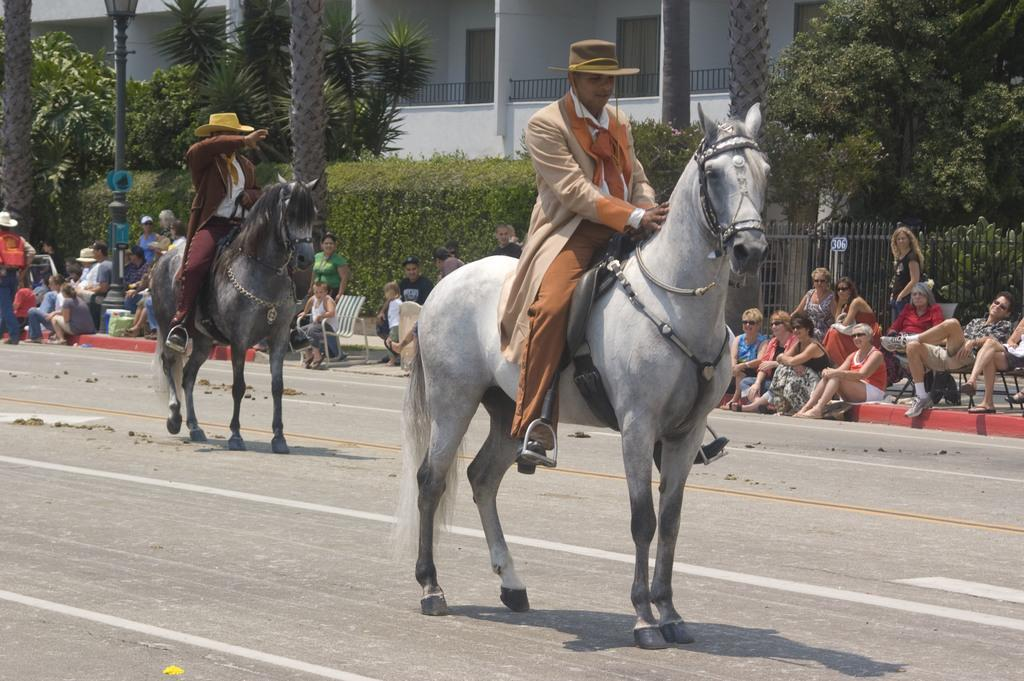What are the people in the image doing? The people in the image are sitting. Can you describe the position of two people in the image? Two people are sitting on horses. What can be seen in the background of the image? There are plants, trees, and a building in the background of the image. What is the cent value of the coin in the image? There is no coin present in the image. What type of corn can be seen growing in the background of the image? There is no corn visible in the image; only plants, trees, and a building are present in the background. 